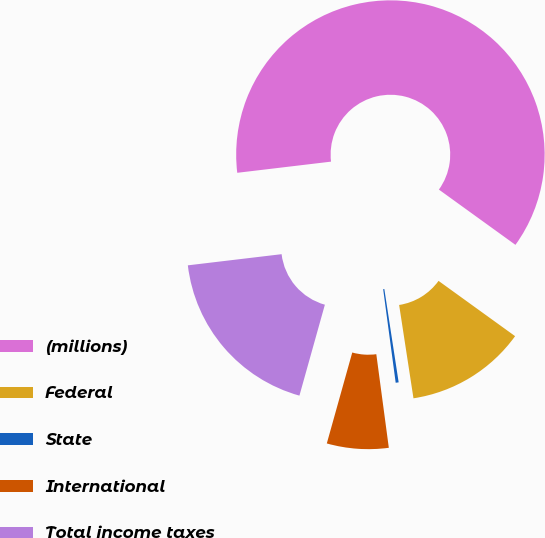Convert chart. <chart><loc_0><loc_0><loc_500><loc_500><pie_chart><fcel>(millions)<fcel>Federal<fcel>State<fcel>International<fcel>Total income taxes<nl><fcel>61.84%<fcel>12.62%<fcel>0.31%<fcel>6.46%<fcel>18.77%<nl></chart> 